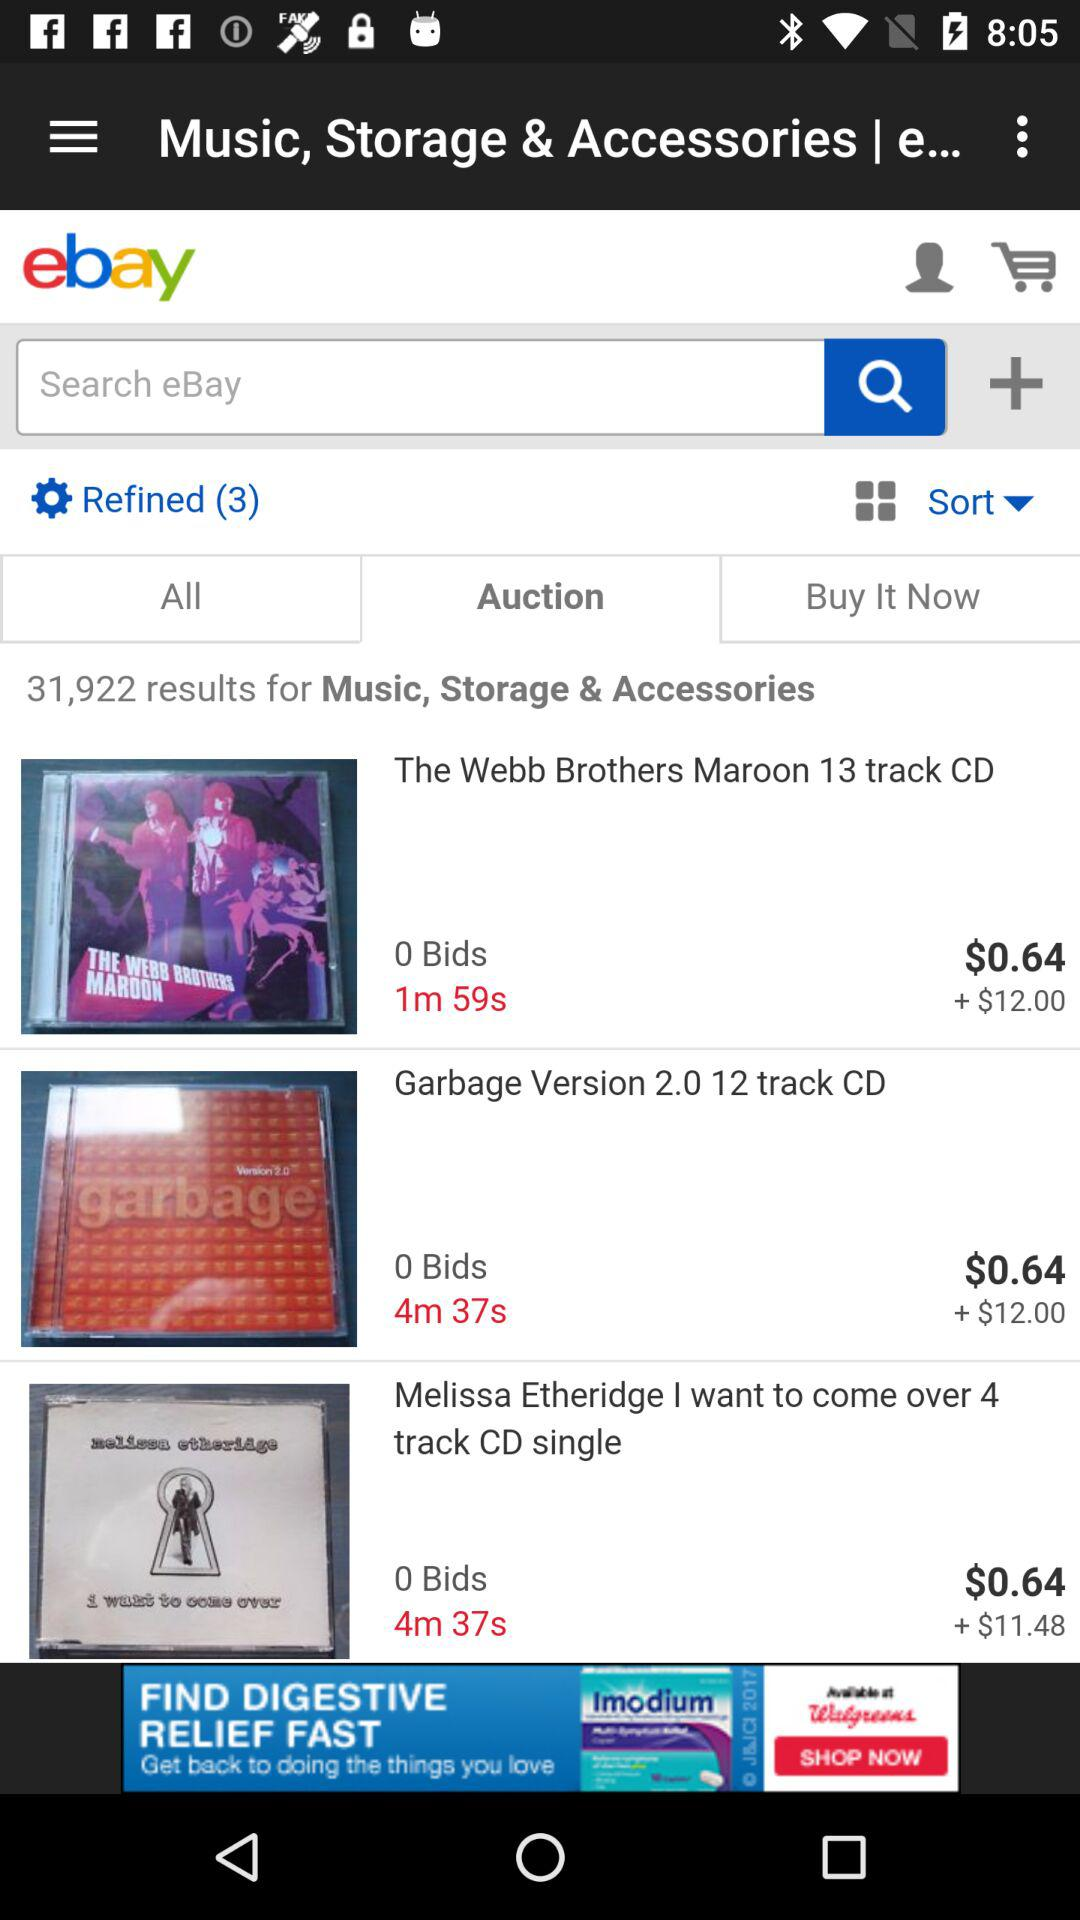What is the total number of refined items? The total number of refined items is 3. 